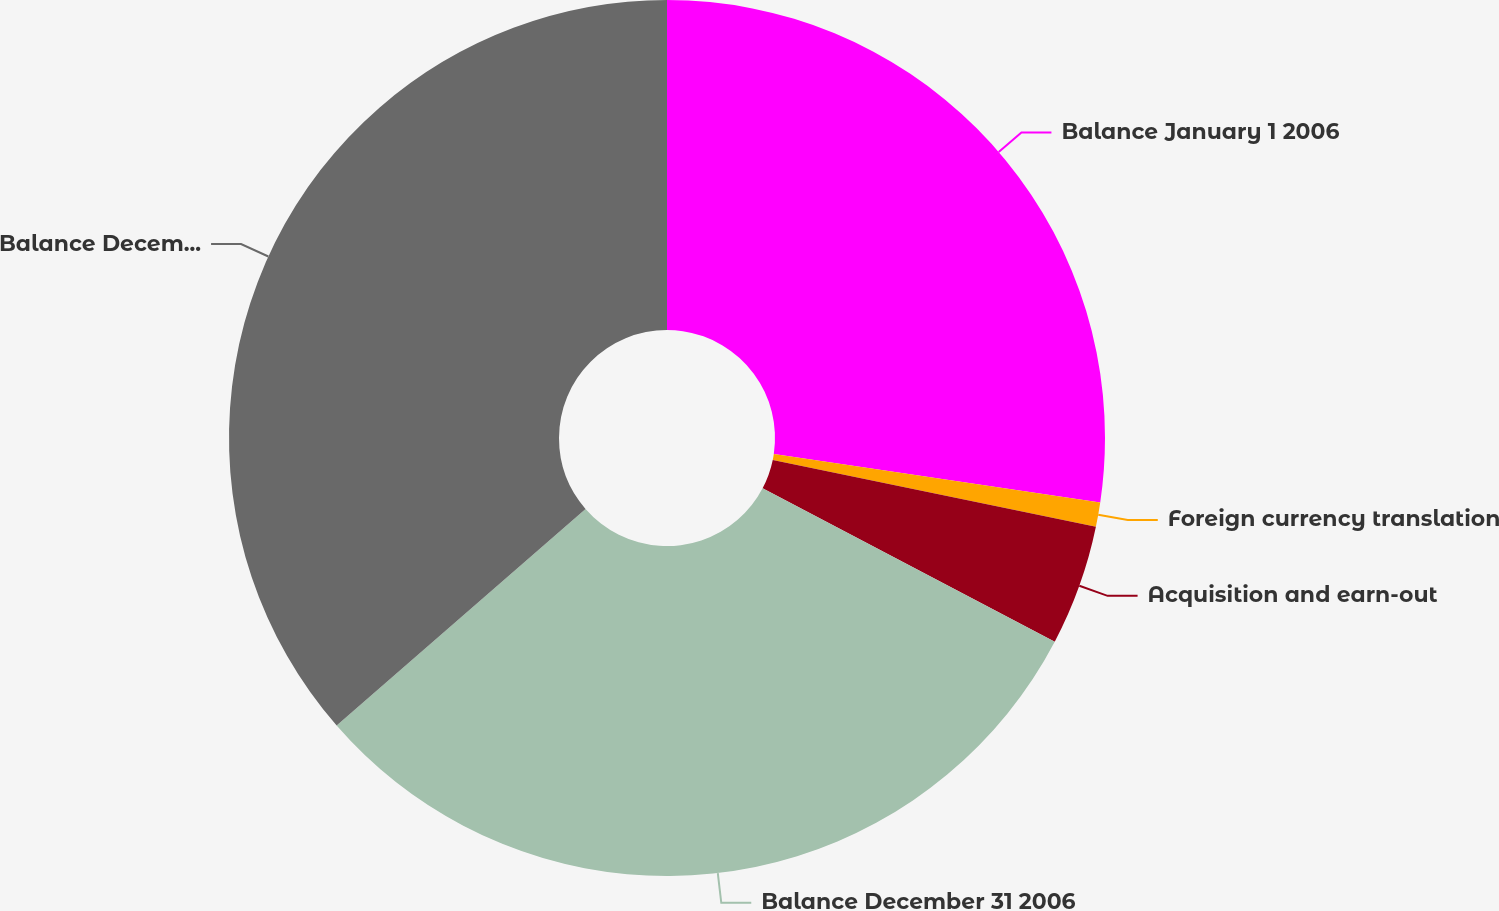Convert chart to OTSL. <chart><loc_0><loc_0><loc_500><loc_500><pie_chart><fcel>Balance January 1 2006<fcel>Foreign currency translation<fcel>Acquisition and earn-out<fcel>Balance December 31 2006<fcel>Balance December 30 2007<nl><fcel>27.35%<fcel>0.9%<fcel>4.45%<fcel>30.9%<fcel>36.4%<nl></chart> 